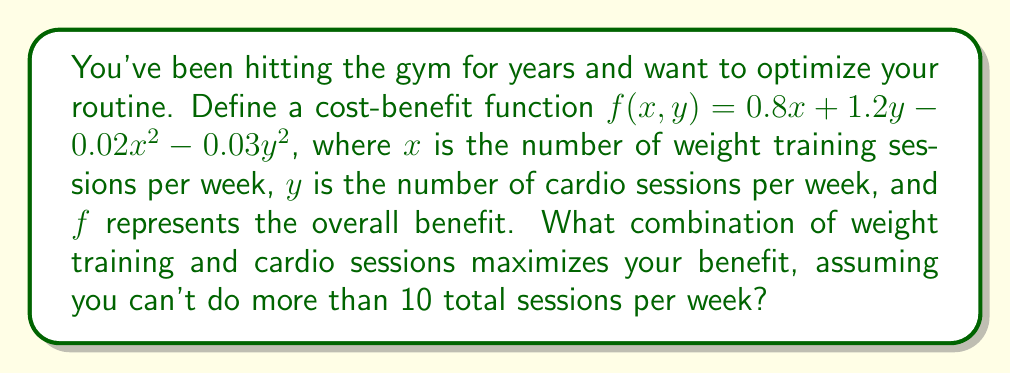Can you answer this question? 1) First, we need to find the maximum of the function $f(x,y) = 0.8x + 1.2y - 0.02x^2 - 0.03y^2$ subject to the constraint $x + y \leq 10$.

2) To find the maximum, we'll use the method of Lagrange multipliers. Let's define:
   $L(x,y,\lambda) = f(x,y) + \lambda(10 - x - y)$

3) Now, we set the partial derivatives equal to zero:
   $$\frac{\partial L}{\partial x} = 0.8 - 0.04x - \lambda = 0$$
   $$\frac{\partial L}{\partial y} = 1.2 - 0.06y - \lambda = 0$$
   $$\frac{\partial L}{\partial \lambda} = 10 - x - y = 0$$

4) From the first two equations:
   $0.8 - 0.04x = 1.2 - 0.06y$
   $0.06y - 0.04x = 0.4$
   $3y - 2x = 20$

5) Substituting $y = 10 - x$ from the third equation:
   $3(10-x) - 2x = 20$
   $30 - 3x - 2x = 20$
   $10 = 5x$
   $x = 2$

6) Thus, $y = 10 - 2 = 8$

7) To verify this is a maximum, we can check the second derivatives:
   $$\frac{\partial^2 f}{\partial x^2} = -0.04 < 0$$
   $$\frac{\partial^2 f}{\partial y^2} = -0.06 < 0$$

   This confirms we've found a maximum.

8) Therefore, the optimal combination is 2 weight training sessions and 8 cardio sessions per week.
Answer: 2 weight training sessions, 8 cardio sessions 